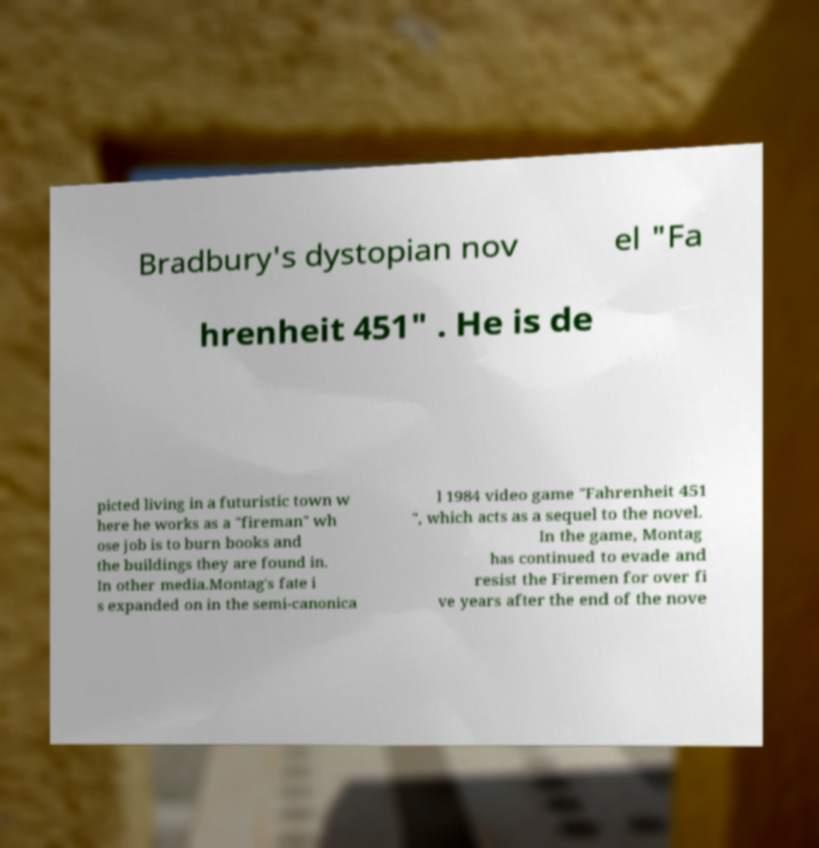There's text embedded in this image that I need extracted. Can you transcribe it verbatim? Bradbury's dystopian nov el "Fa hrenheit 451" . He is de picted living in a futuristic town w here he works as a "fireman" wh ose job is to burn books and the buildings they are found in. In other media.Montag's fate i s expanded on in the semi-canonica l 1984 video game "Fahrenheit 451 ", which acts as a sequel to the novel. In the game, Montag has continued to evade and resist the Firemen for over fi ve years after the end of the nove 